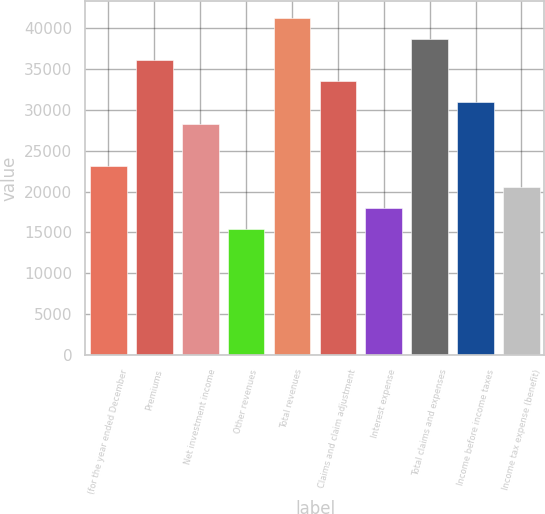Convert chart. <chart><loc_0><loc_0><loc_500><loc_500><bar_chart><fcel>(for the year ended December<fcel>Premiums<fcel>Net investment income<fcel>Other revenues<fcel>Total revenues<fcel>Claims and claim adjustment<fcel>Interest expense<fcel>Total claims and expenses<fcel>Income before income taxes<fcel>Income tax expense (benefit)<nl><fcel>23166.1<fcel>36035.7<fcel>28313.9<fcel>15444.3<fcel>41183.5<fcel>33461.8<fcel>18018.2<fcel>38609.6<fcel>30887.8<fcel>20592.2<nl></chart> 